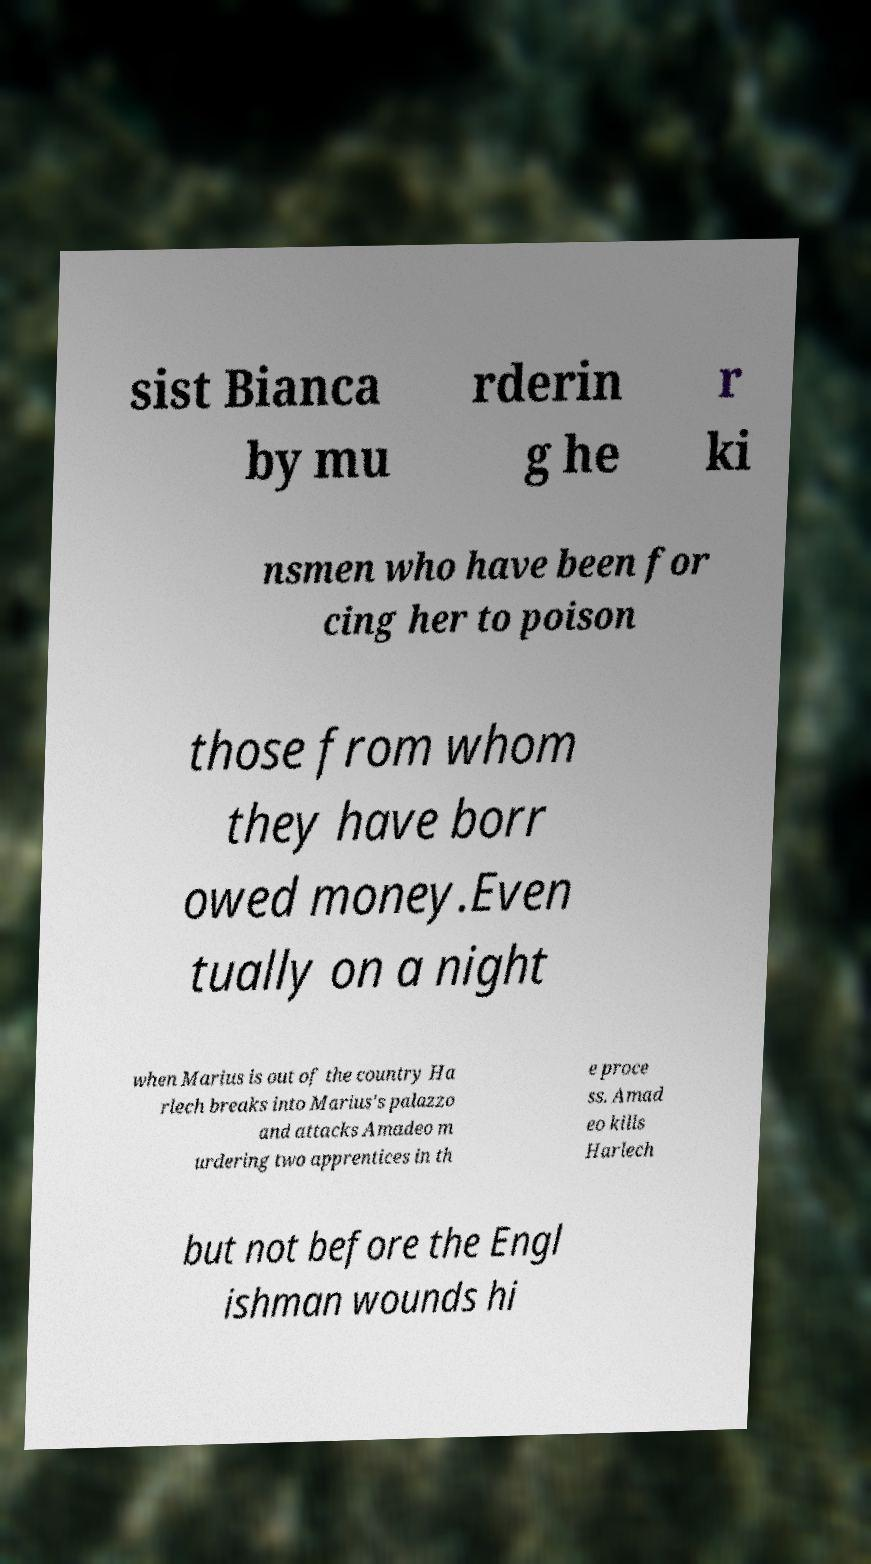Please identify and transcribe the text found in this image. sist Bianca by mu rderin g he r ki nsmen who have been for cing her to poison those from whom they have borr owed money.Even tually on a night when Marius is out of the country Ha rlech breaks into Marius's palazzo and attacks Amadeo m urdering two apprentices in th e proce ss. Amad eo kills Harlech but not before the Engl ishman wounds hi 